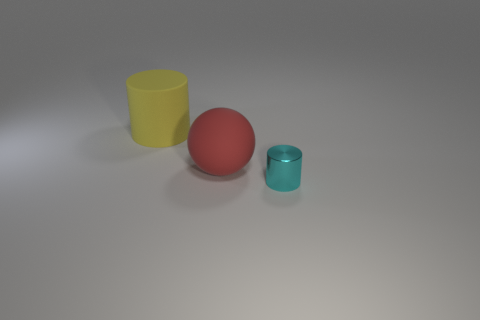Does the red object have the same shape as the big yellow object?
Your answer should be compact. No. What number of metal things are either tiny cyan cylinders or large red things?
Keep it short and to the point. 1. Is there a rubber cylinder that has the same size as the cyan metal cylinder?
Your answer should be compact. No. How many cyan shiny cylinders are the same size as the yellow matte object?
Give a very brief answer. 0. Does the rubber object that is in front of the big yellow cylinder have the same size as the metal thing on the right side of the large yellow matte cylinder?
Make the answer very short. No. How many things are large objects or objects that are on the left side of the metallic thing?
Your response must be concise. 2. The tiny shiny cylinder is what color?
Give a very brief answer. Cyan. The big thing that is to the left of the large rubber thing in front of the cylinder that is left of the cyan object is made of what material?
Keep it short and to the point. Rubber. What is the size of the other object that is made of the same material as the big red thing?
Keep it short and to the point. Large. Is there a small metallic thing of the same color as the big rubber sphere?
Give a very brief answer. No. 